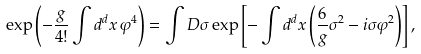Convert formula to latex. <formula><loc_0><loc_0><loc_500><loc_500>\exp \left ( - \frac { g } { 4 ! } \int d ^ { d } x \, \varphi ^ { 4 } \right ) = \int D \sigma \exp \left [ - \int d ^ { d } x \left ( \frac { 6 } { g } \sigma ^ { 2 } - i \sigma \varphi ^ { 2 } \right ) \right ] ,</formula> 